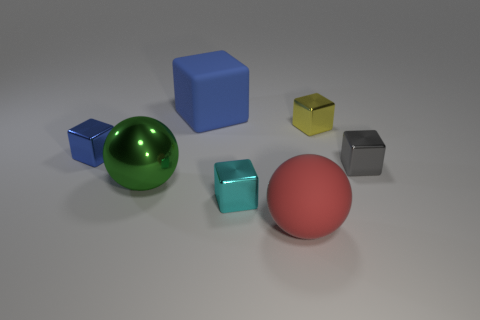The large green shiny object is what shape?
Offer a terse response. Sphere. How big is the matte object behind the tiny thing in front of the tiny gray metal block?
Provide a short and direct response. Large. Are there an equal number of red rubber balls in front of the gray block and small cyan metallic things right of the yellow metallic object?
Offer a terse response. No. There is a object that is left of the small yellow metallic block and on the right side of the small cyan metal block; what is its material?
Your answer should be compact. Rubber. Does the matte block have the same size as the blue object that is left of the big blue rubber object?
Offer a very short reply. No. How many other objects are there of the same color as the big cube?
Offer a very short reply. 1. Is the number of small blue blocks on the right side of the yellow block greater than the number of blue metallic objects?
Provide a short and direct response. No. There is a tiny cube in front of the tiny gray shiny object that is right of the tiny metal cube that is left of the large matte cube; what color is it?
Give a very brief answer. Cyan. Do the red ball and the big green sphere have the same material?
Make the answer very short. No. Is there a ball that has the same size as the blue shiny thing?
Your answer should be very brief. No. 